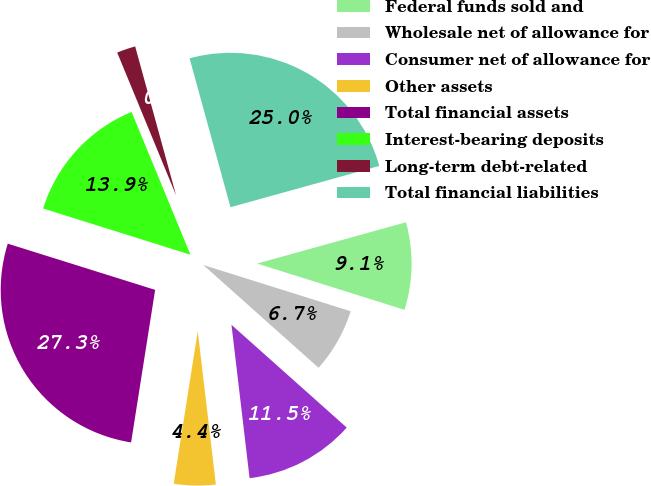Convert chart. <chart><loc_0><loc_0><loc_500><loc_500><pie_chart><fcel>Federal funds sold and<fcel>Wholesale net of allowance for<fcel>Consumer net of allowance for<fcel>Other assets<fcel>Total financial assets<fcel>Interest-bearing deposits<fcel>Long-term debt-related<fcel>Total financial liabilities<nl><fcel>9.15%<fcel>6.75%<fcel>11.54%<fcel>4.36%<fcel>27.35%<fcel>13.94%<fcel>1.96%<fcel>24.96%<nl></chart> 